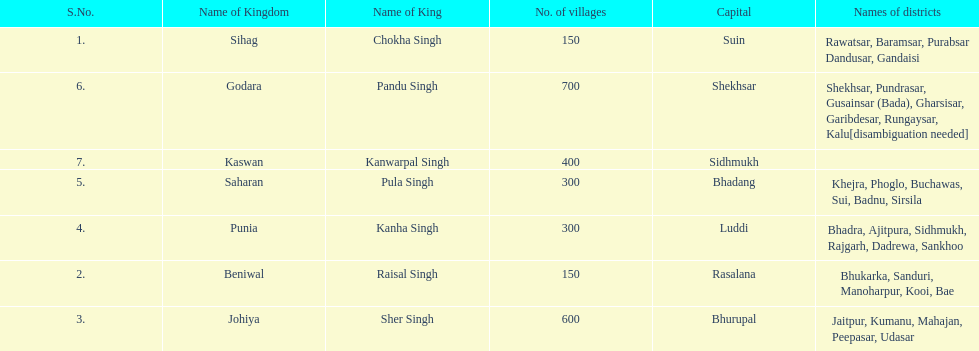He was the king of the sihag kingdom. Chokha Singh. 